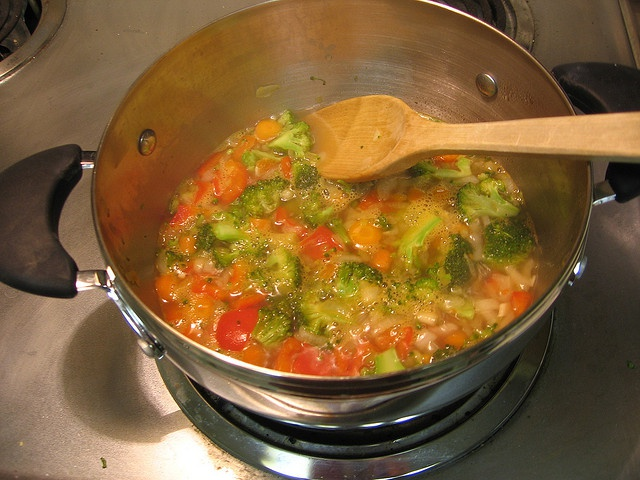Describe the objects in this image and their specific colors. I can see spoon in black, tan, orange, olive, and maroon tones, broccoli in black, olive, and orange tones, broccoli in black, olive, and orange tones, broccoli in black, olive, and red tones, and broccoli in black and olive tones in this image. 